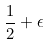<formula> <loc_0><loc_0><loc_500><loc_500>\frac { 1 } { 2 } + \epsilon</formula> 